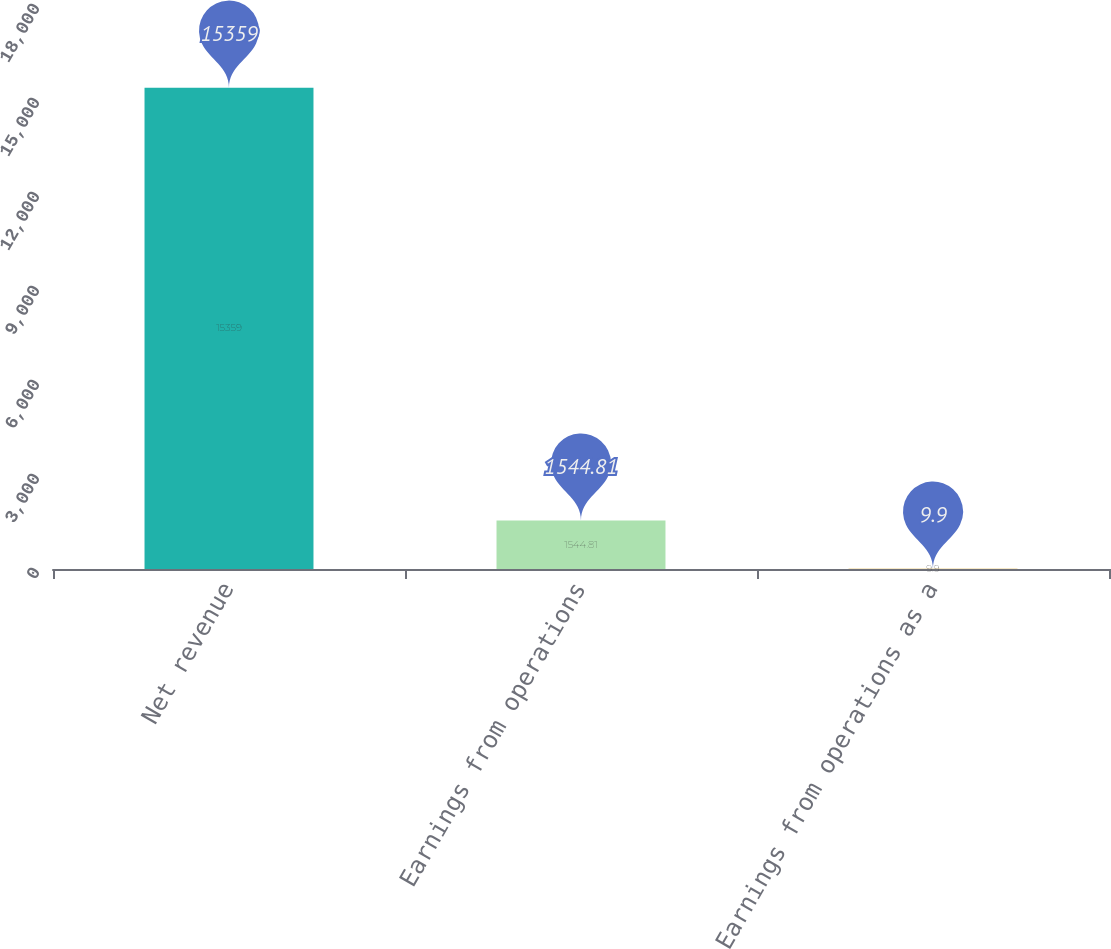<chart> <loc_0><loc_0><loc_500><loc_500><bar_chart><fcel>Net revenue<fcel>Earnings from operations<fcel>Earnings from operations as a<nl><fcel>15359<fcel>1544.81<fcel>9.9<nl></chart> 